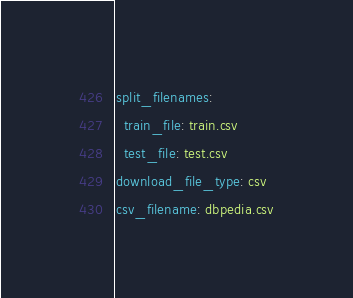<code> <loc_0><loc_0><loc_500><loc_500><_YAML_>split_filenames:
  train_file: train.csv
  test_file: test.csv
download_file_type: csv
csv_filename: dbpedia.csv</code> 